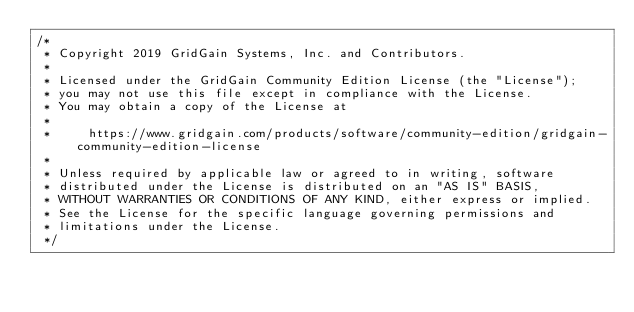Convert code to text. <code><loc_0><loc_0><loc_500><loc_500><_Java_>/*
 * Copyright 2019 GridGain Systems, Inc. and Contributors.
 *
 * Licensed under the GridGain Community Edition License (the "License");
 * you may not use this file except in compliance with the License.
 * You may obtain a copy of the License at
 *
 *     https://www.gridgain.com/products/software/community-edition/gridgain-community-edition-license
 *
 * Unless required by applicable law or agreed to in writing, software
 * distributed under the License is distributed on an "AS IS" BASIS,
 * WITHOUT WARRANTIES OR CONDITIONS OF ANY KIND, either express or implied.
 * See the License for the specific language governing permissions and
 * limitations under the License.
 */
</code> 